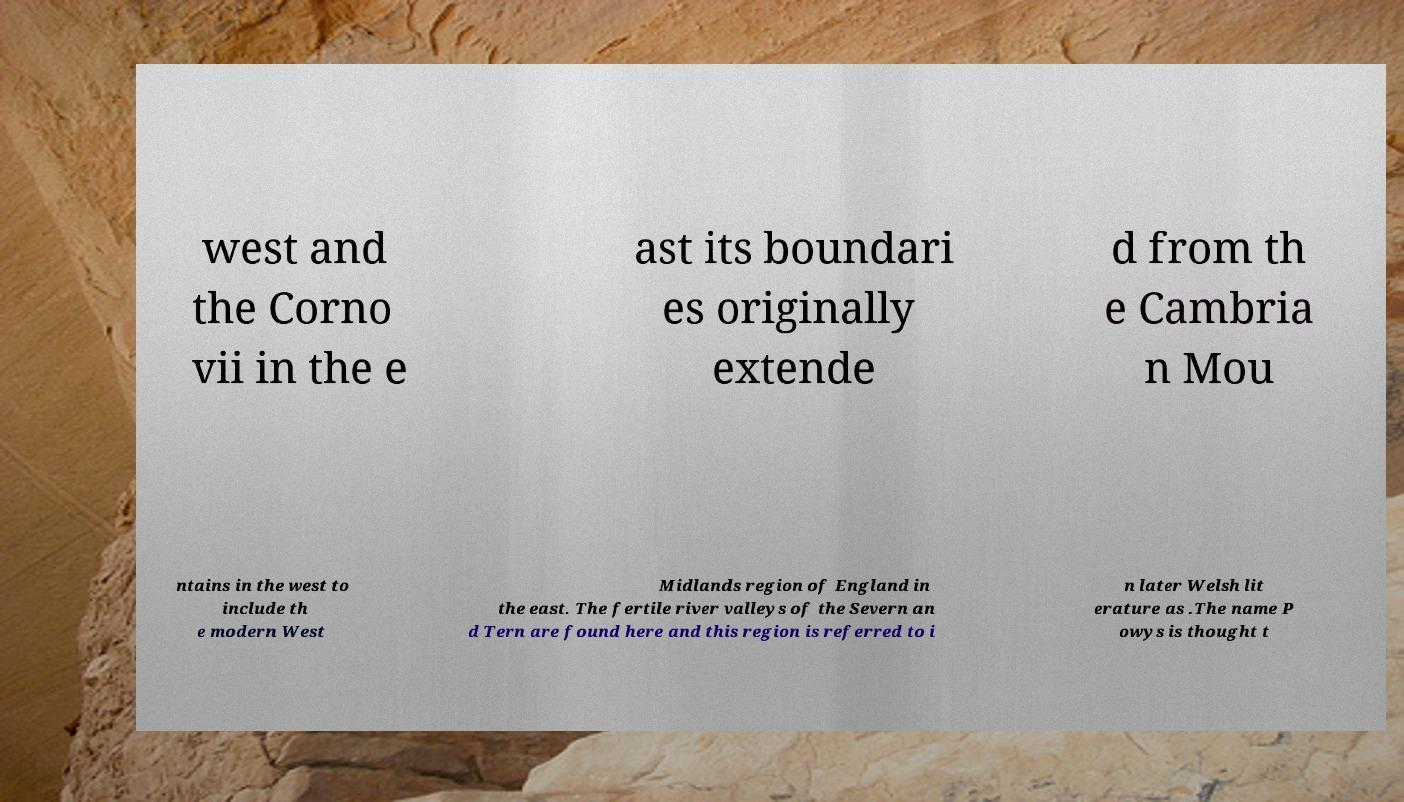Please identify and transcribe the text found in this image. west and the Corno vii in the e ast its boundari es originally extende d from th e Cambria n Mou ntains in the west to include th e modern West Midlands region of England in the east. The fertile river valleys of the Severn an d Tern are found here and this region is referred to i n later Welsh lit erature as .The name P owys is thought t 